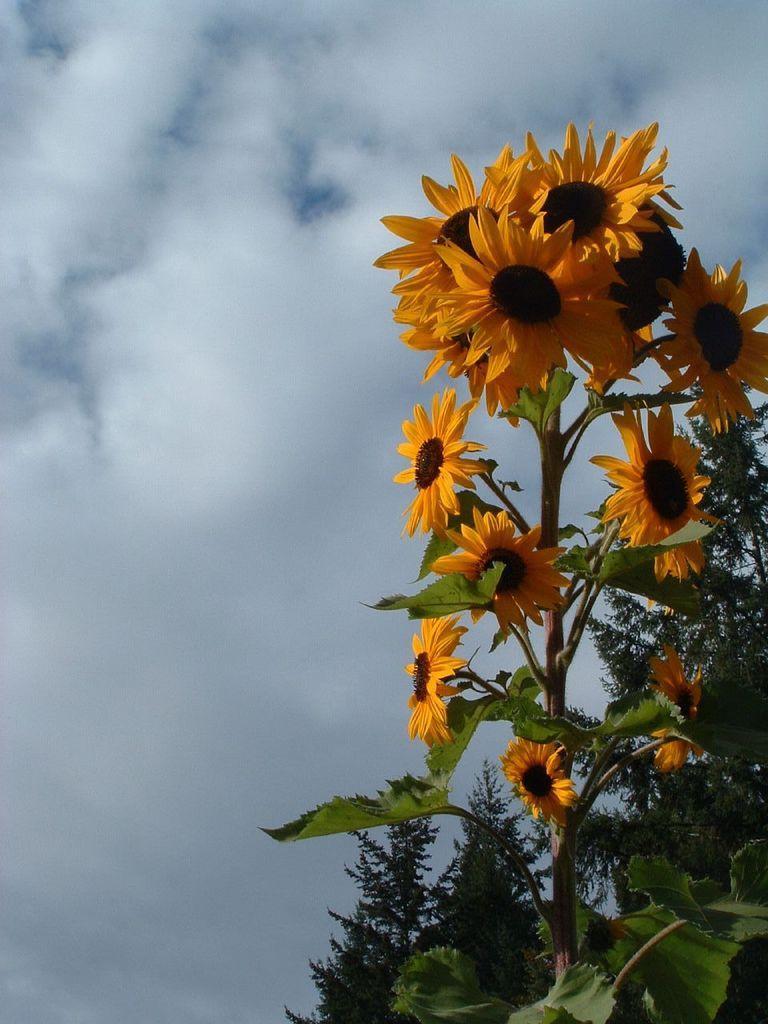Could you give a brief overview of what you see in this image? There is a stem which has few sunflowers on it. 